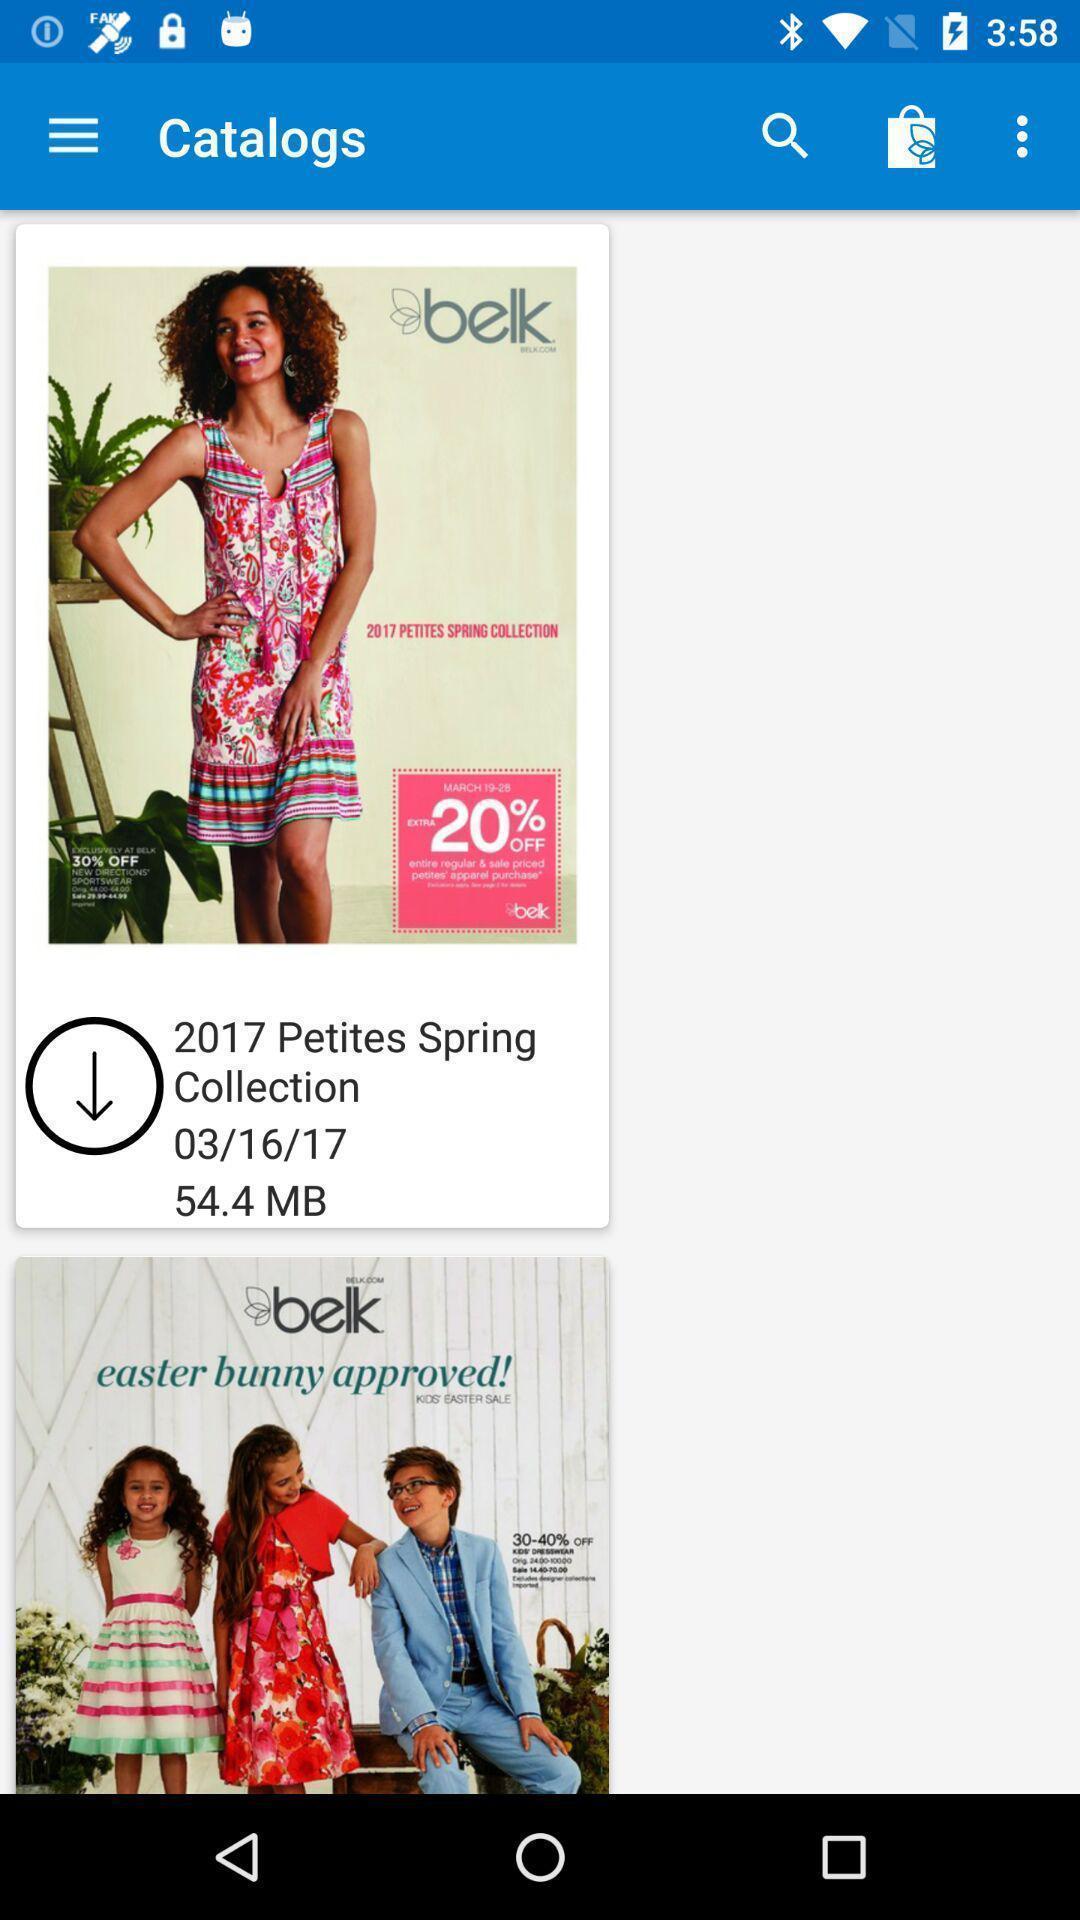Provide a textual representation of this image. Screen showing catalogs on an app. 